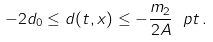<formula> <loc_0><loc_0><loc_500><loc_500>- 2 d _ { 0 } \leq d ( t , x ) \leq - \frac { m _ { 2 } } { 2 A } \ p t \, .</formula> 